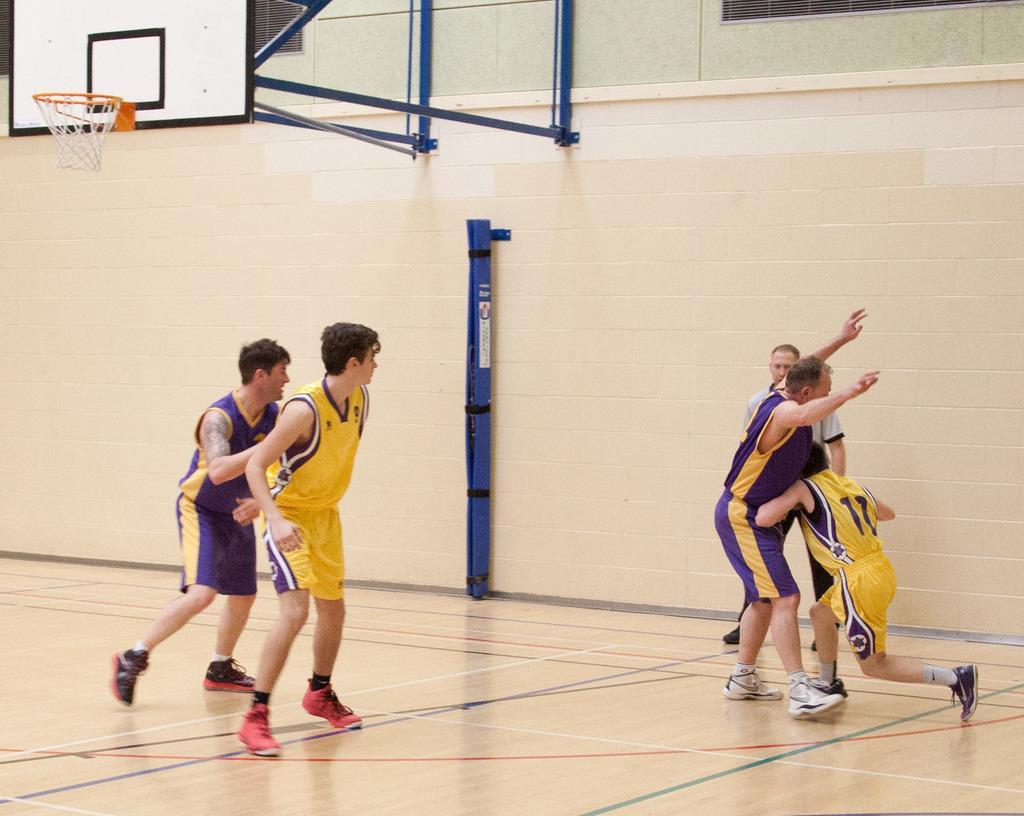In one or two sentences, can you explain what this image depicts? In this picture I can observe four members playing basketball in the court. I can observe violet and yellow color jerseys. On the top left side I can observe a basketball net. In the background there is a wall. 